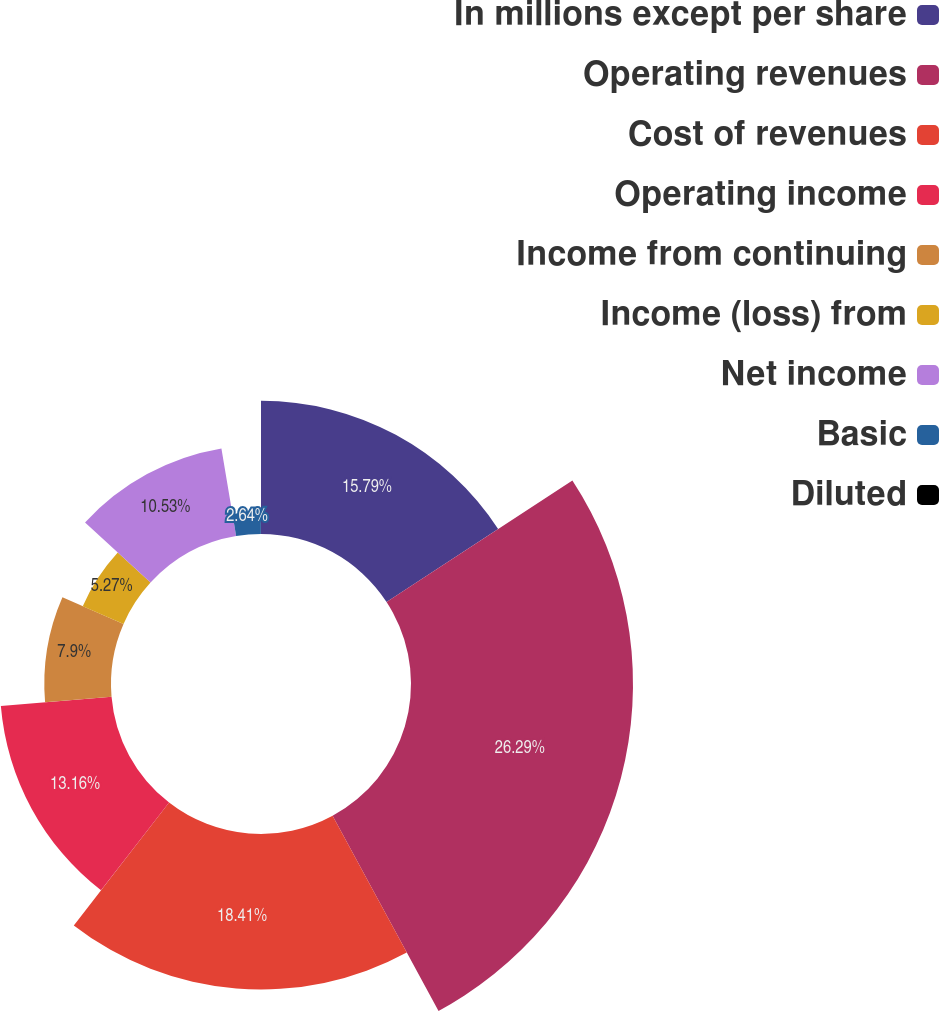<chart> <loc_0><loc_0><loc_500><loc_500><pie_chart><fcel>In millions except per share<fcel>Operating revenues<fcel>Cost of revenues<fcel>Operating income<fcel>Income from continuing<fcel>Income (loss) from<fcel>Net income<fcel>Basic<fcel>Diluted<nl><fcel>15.79%<fcel>26.3%<fcel>18.42%<fcel>13.16%<fcel>7.9%<fcel>5.27%<fcel>10.53%<fcel>2.64%<fcel>0.01%<nl></chart> 